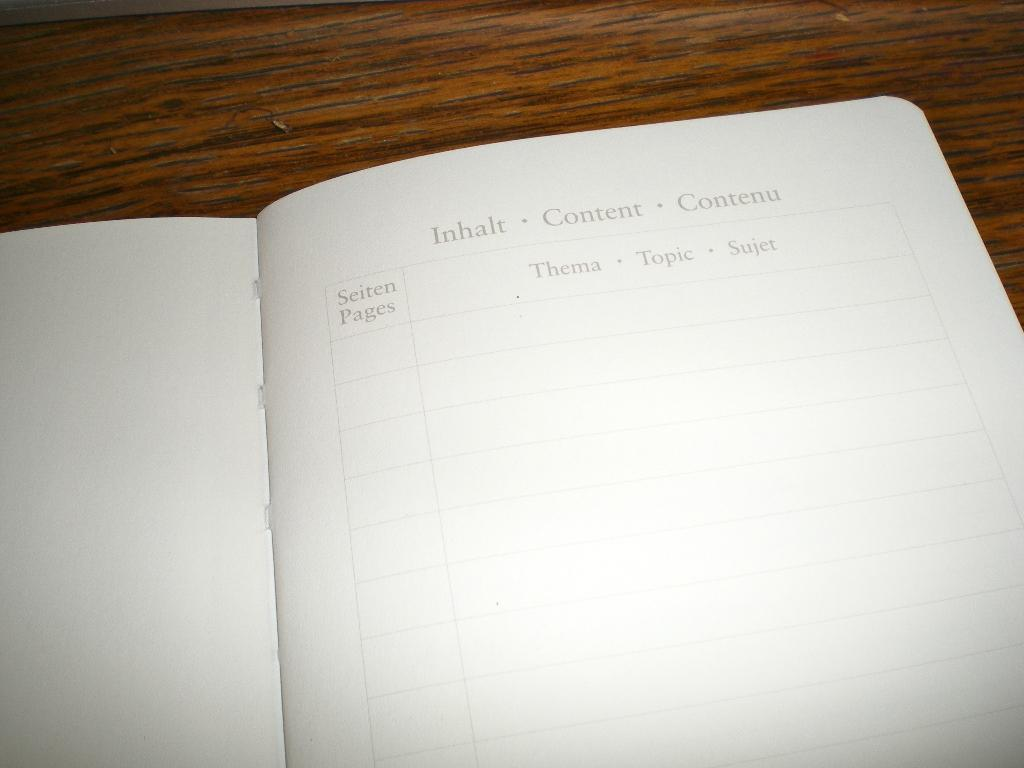<image>
Provide a brief description of the given image. A book is open to a page that says Content at the top. 